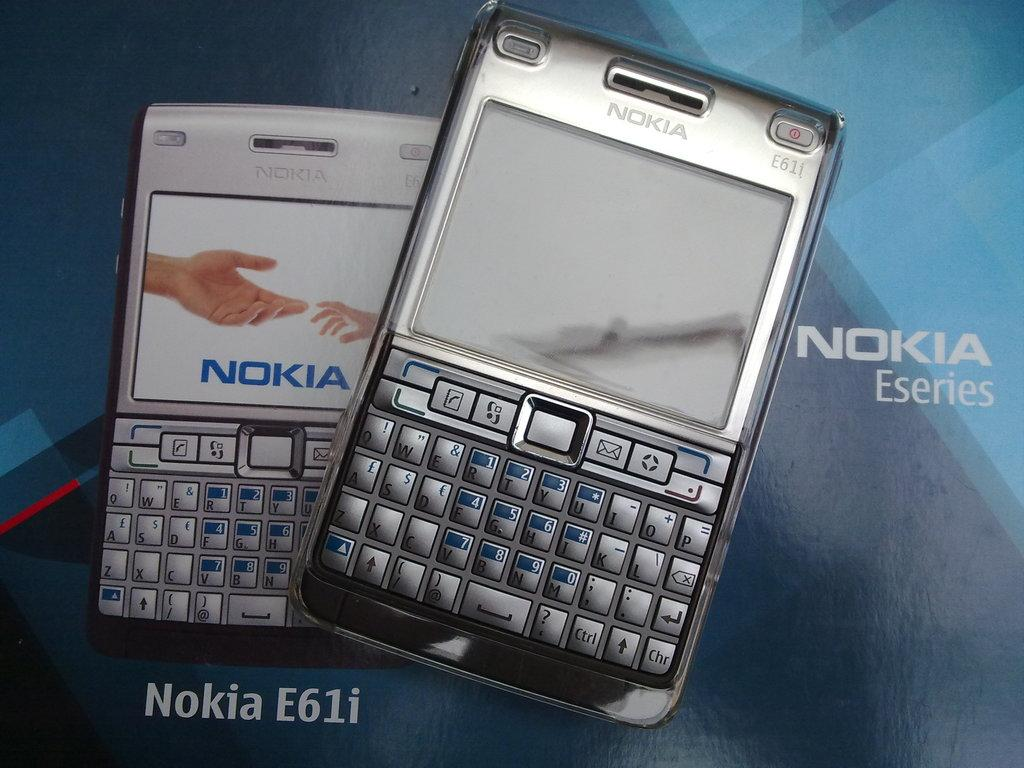<image>
Create a compact narrative representing the image presented. two nokia e61i phones  on a multishaded blue nokia background 